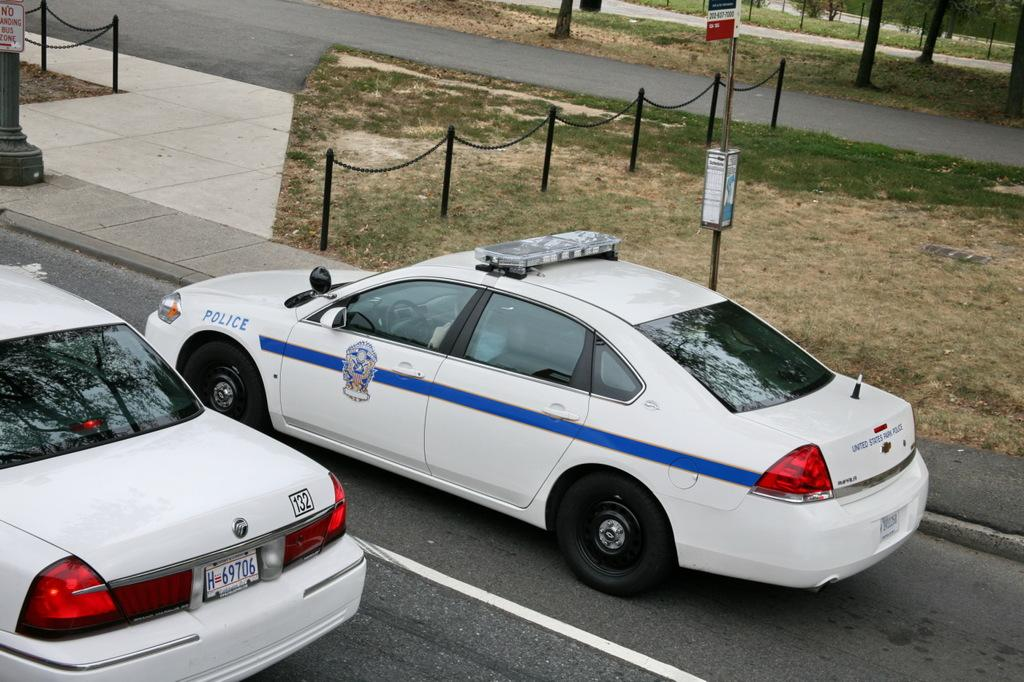How many cars can be seen in the image? There are two cars in the image. What is present on the grass in the image? Small poles with chains are present on the grass. What safety measure is visible in the image? A caution board is visible in the image. Where is the caution board placed in relation to the small pillar? The caution board is placed in front of a small pillar. Are there any pets visible in the image? No, there are no pets present in the image. What type of thrill can be experienced by driving on the street shown in the image? The image does not show a street, so it is not possible to determine what type of thrill might be experienced by driving on it. 